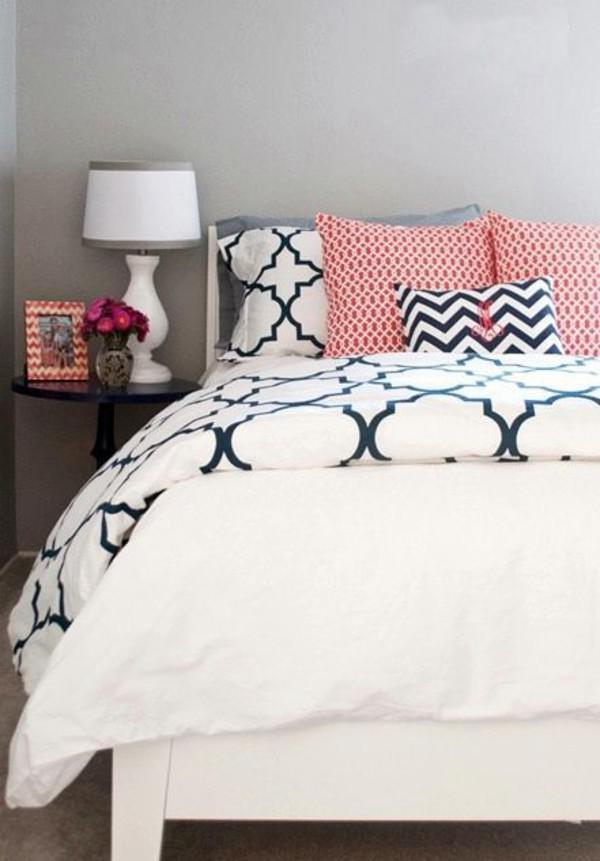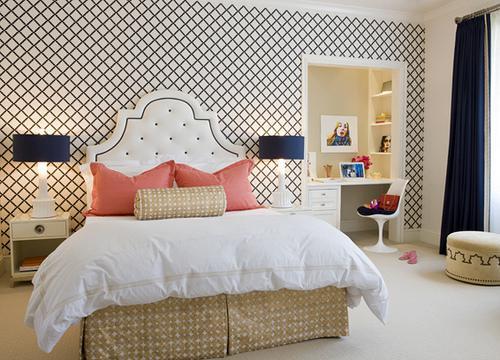The first image is the image on the left, the second image is the image on the right. Evaluate the accuracy of this statement regarding the images: "The right image shows a narrow pillow centered in front of side-by-side pillows on a bed with an upholstered arch-topped headboard.". Is it true? Answer yes or no. Yes. The first image is the image on the left, the second image is the image on the right. Examine the images to the left and right. Is the description "In at least one image there is a bed with a light colored comforter and an arched triangle like bed board." accurate? Answer yes or no. Yes. 